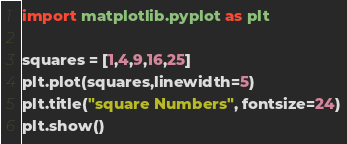<code> <loc_0><loc_0><loc_500><loc_500><_Python_>import matplotlib.pyplot as plt

squares = [1,4,9,16,25]
plt.plot(squares,linewidth=5)
plt.title("square Numbers", fontsize=24)
plt.show()</code> 